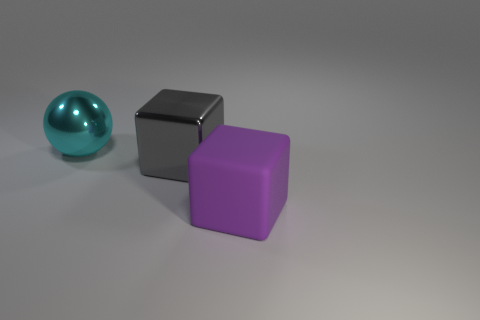Are there any purple matte things of the same size as the gray metal cube?
Provide a succinct answer. Yes. Is the number of large balls that are in front of the big cyan sphere less than the number of things?
Offer a terse response. Yes. Is the number of large purple rubber cubes in front of the big purple matte cube less than the number of objects that are in front of the metal block?
Provide a succinct answer. Yes. There is a big shiny object that is in front of the big cyan metal ball; is it the same shape as the purple object?
Provide a short and direct response. Yes. Is there any other thing that is made of the same material as the purple cube?
Provide a short and direct response. No. Is the big cube behind the big matte thing made of the same material as the cyan ball?
Your answer should be compact. Yes. What material is the thing to the left of the large metal object in front of the shiny thing to the left of the gray metallic cube made of?
Your answer should be compact. Metal. How many other objects are there of the same shape as the cyan shiny thing?
Provide a short and direct response. 0. What is the color of the thing that is in front of the metallic block?
Your answer should be very brief. Purple. How many big spheres are left of the big thing that is behind the block on the left side of the big rubber block?
Offer a very short reply. 0. 